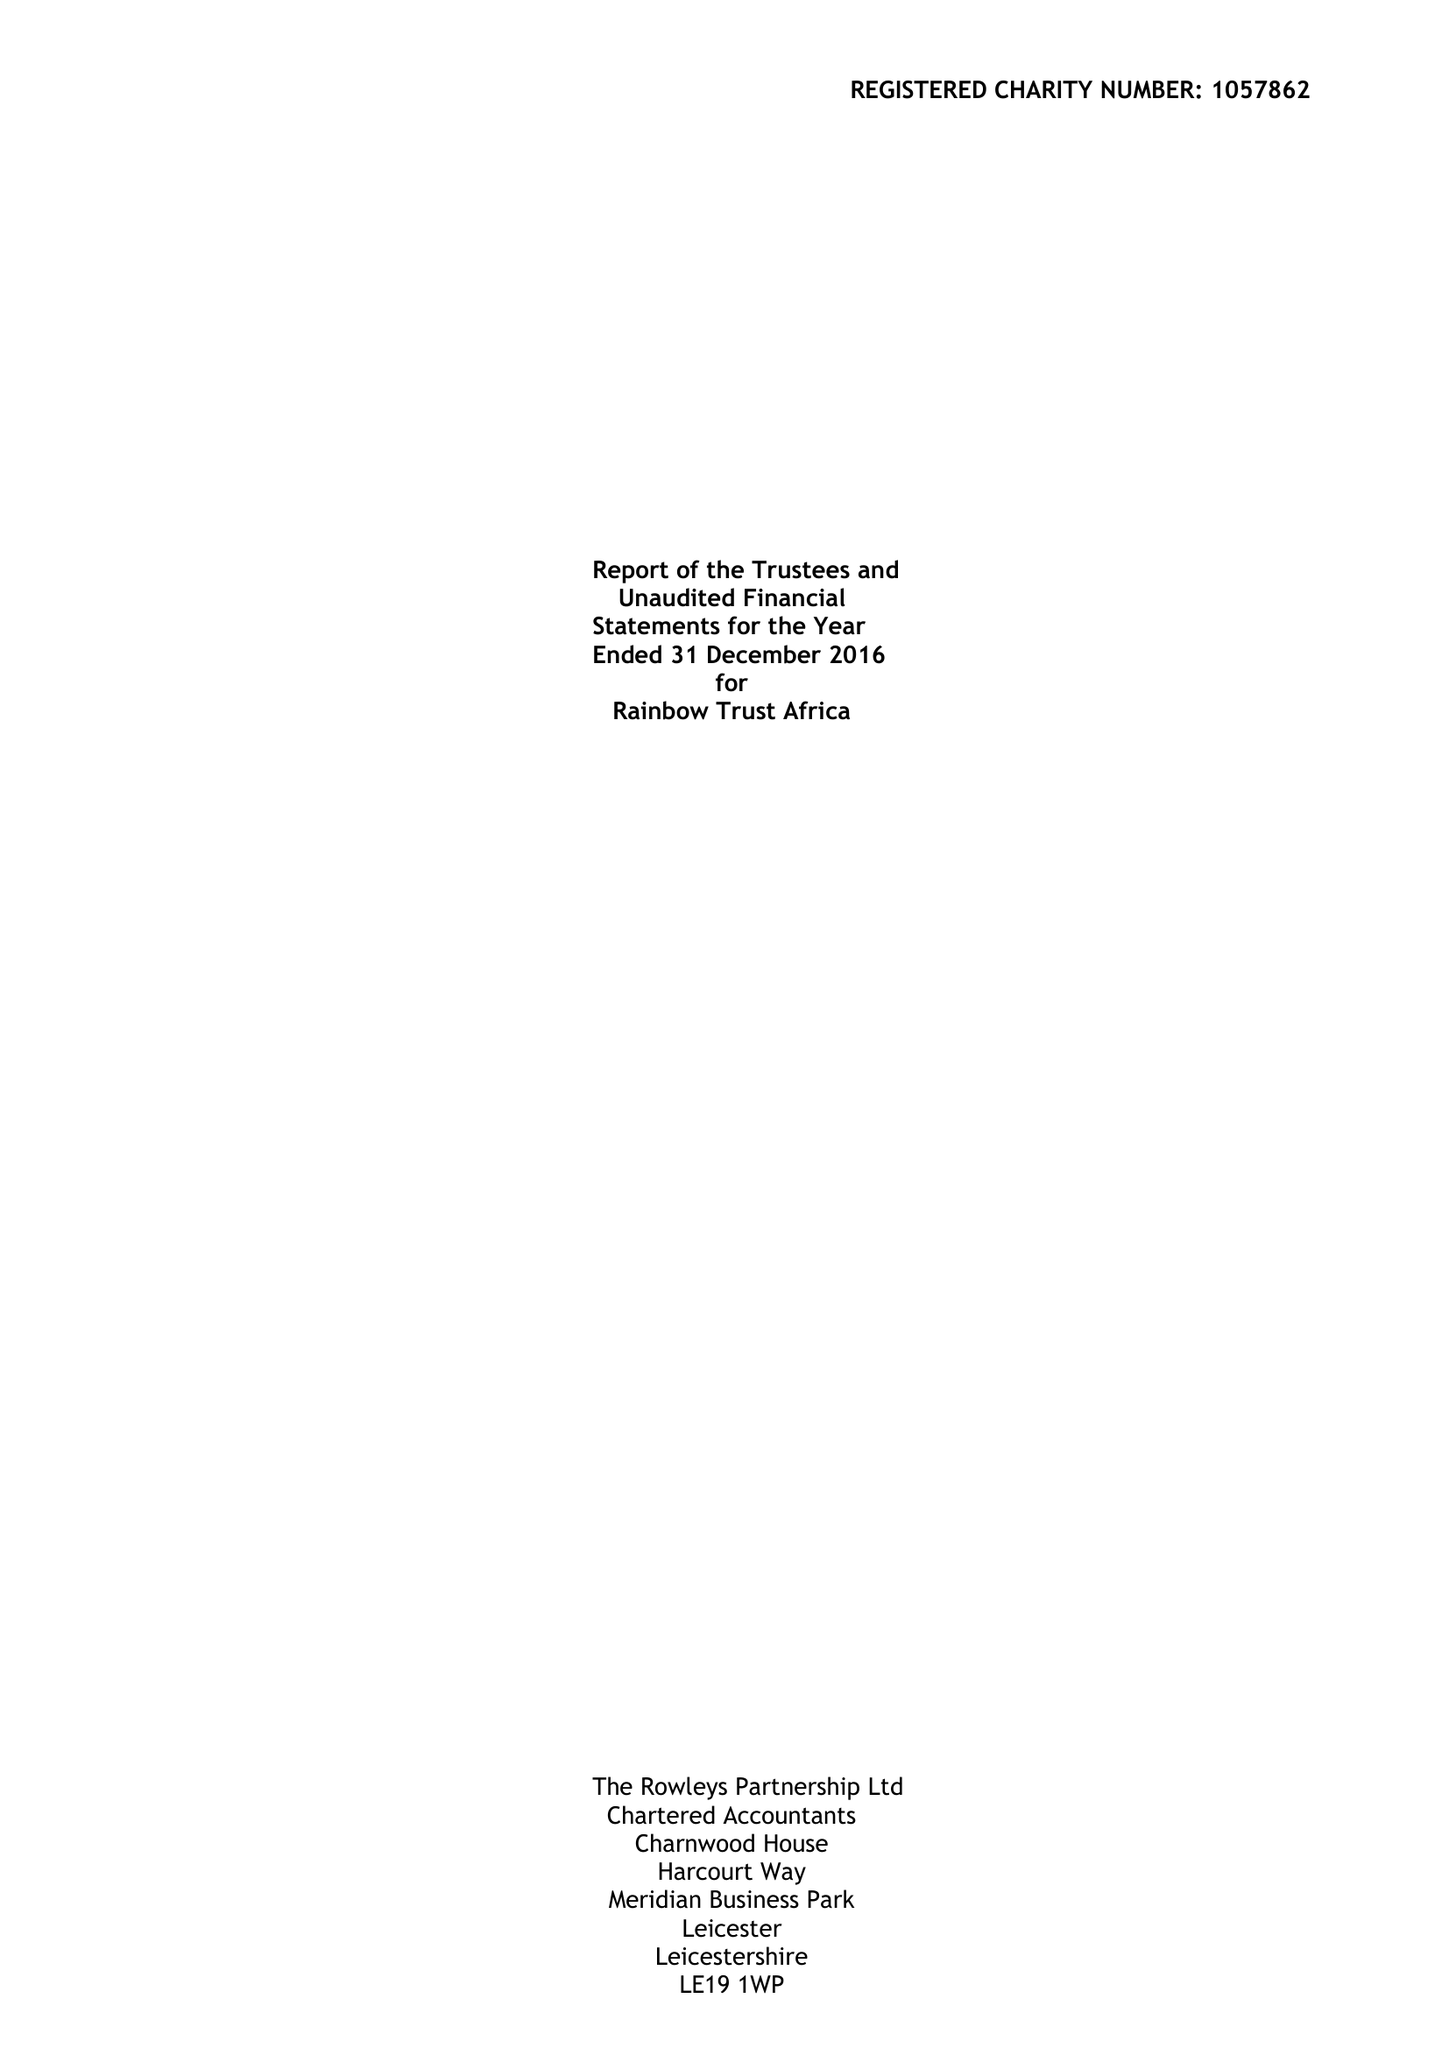What is the value for the spending_annually_in_british_pounds?
Answer the question using a single word or phrase. 275215.00 